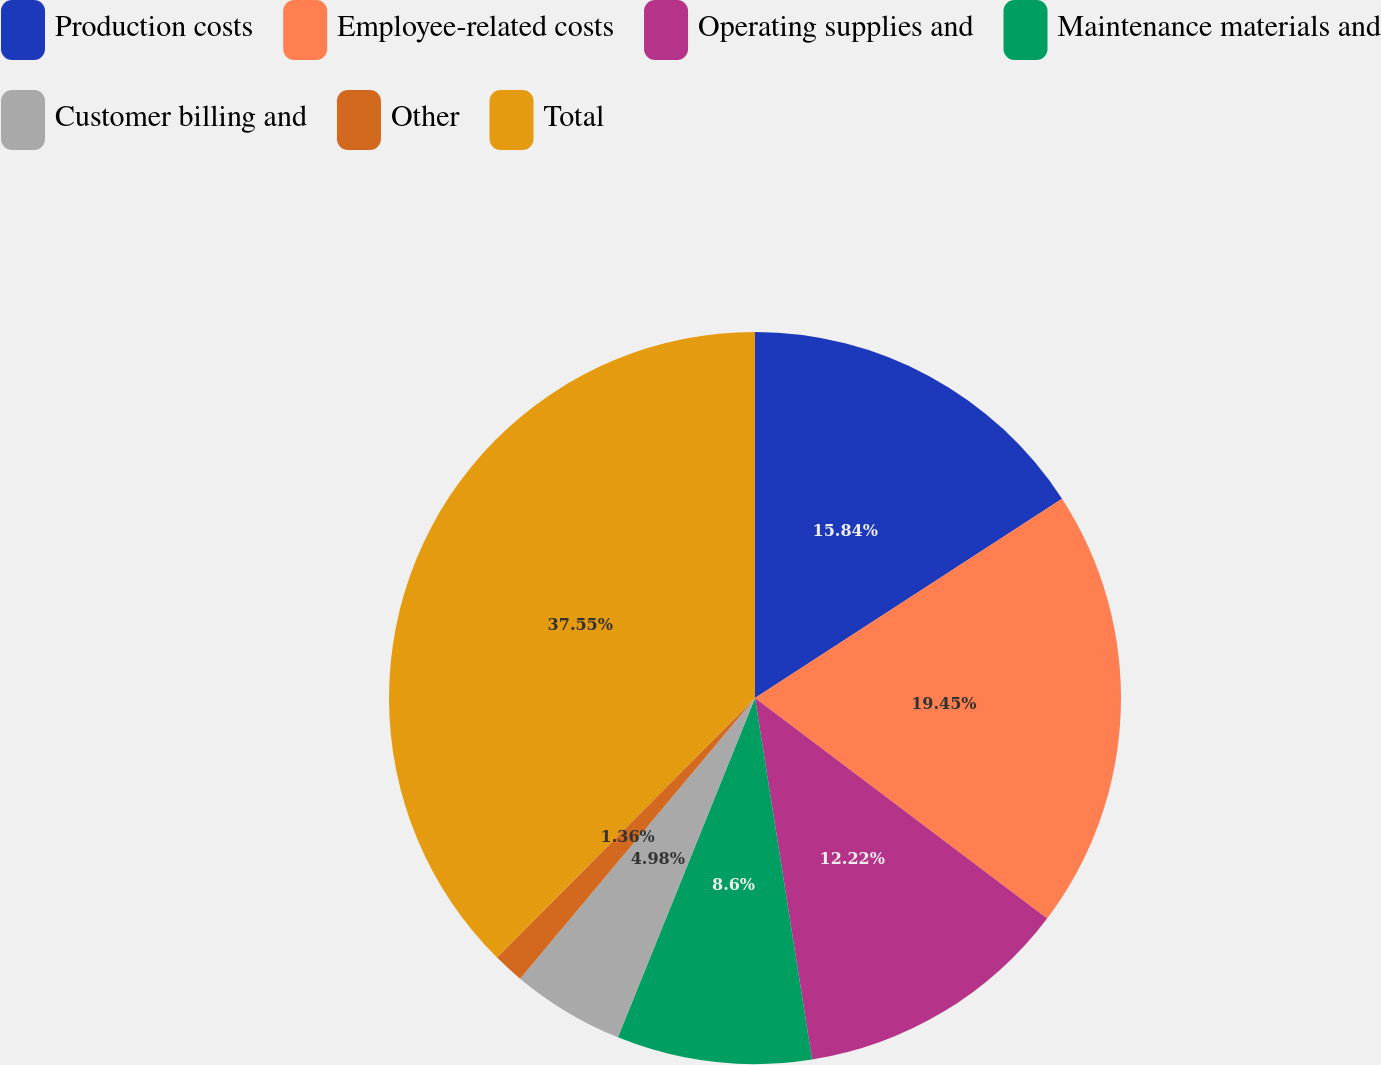<chart> <loc_0><loc_0><loc_500><loc_500><pie_chart><fcel>Production costs<fcel>Employee-related costs<fcel>Operating supplies and<fcel>Maintenance materials and<fcel>Customer billing and<fcel>Other<fcel>Total<nl><fcel>15.84%<fcel>19.45%<fcel>12.22%<fcel>8.6%<fcel>4.98%<fcel>1.36%<fcel>37.55%<nl></chart> 